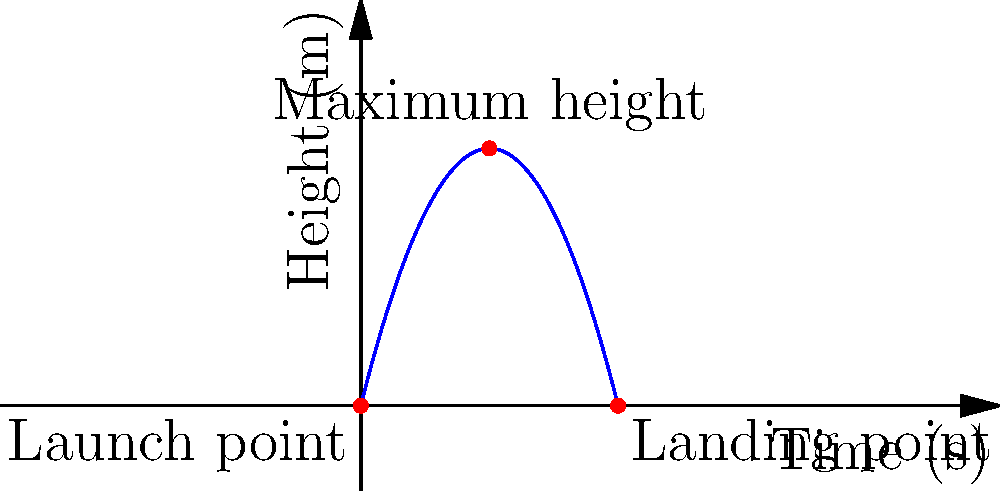In a science experiment, you launch a projectile and track its trajectory. The parabolic graph above shows the height of the projectile over time. What is the total time the projectile is in the air? Let's approach this step-by-step:

1) The parabolic trajectory of a projectile is symmetrical. This means the time to reach the maximum height is equal to the time to fall from the maximum height to the ground.

2) In the graph, we can see that the projectile starts at the origin (0,0) and lands at (8,0).

3) The x-axis represents time, so the total time in the air is the x-coordinate of the landing point.

4) From the graph, we can see that the landing point is at x = 8.

5) Therefore, the total time the projectile is in the air is 8 seconds.

This problem demonstrates how we can extract important information from a graphical representation of motion, a key skill in physics and engineering.
Answer: 8 seconds 